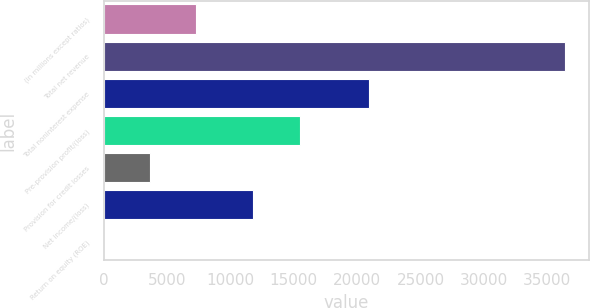Convert chart. <chart><loc_0><loc_0><loc_500><loc_500><bar_chart><fcel>(in millions except ratios)<fcel>Total net revenue<fcel>Total noninterest expense<fcel>Pre-provision profit/(loss)<fcel>Provision for credit losses<fcel>Net income/(loss)<fcel>Return on equity (ROE)<nl><fcel>7302.4<fcel>36448<fcel>20918<fcel>15530<fcel>3659.2<fcel>11773<fcel>16<nl></chart> 